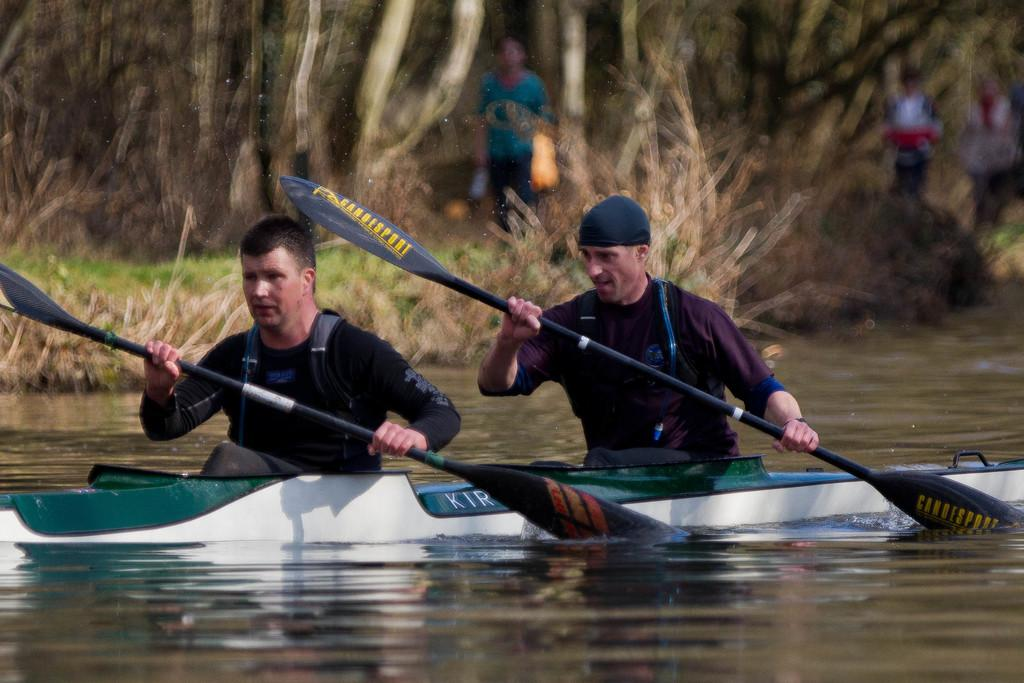How many people are in the image? There are two men in the image. What are the men doing in the image? The men are sitting in a boat. What can be seen in the background of the image? There are people and dried grass in the background of the image. What is the primary setting of the image? The primary setting of the image is water, as the men are sitting in a boat on it. What type of suit is the pin attached to in the image? There is no suit or pin present in the image. What are the men learning while sitting in the boat? The image does not provide information about the men learning anything while sitting in the boat. 